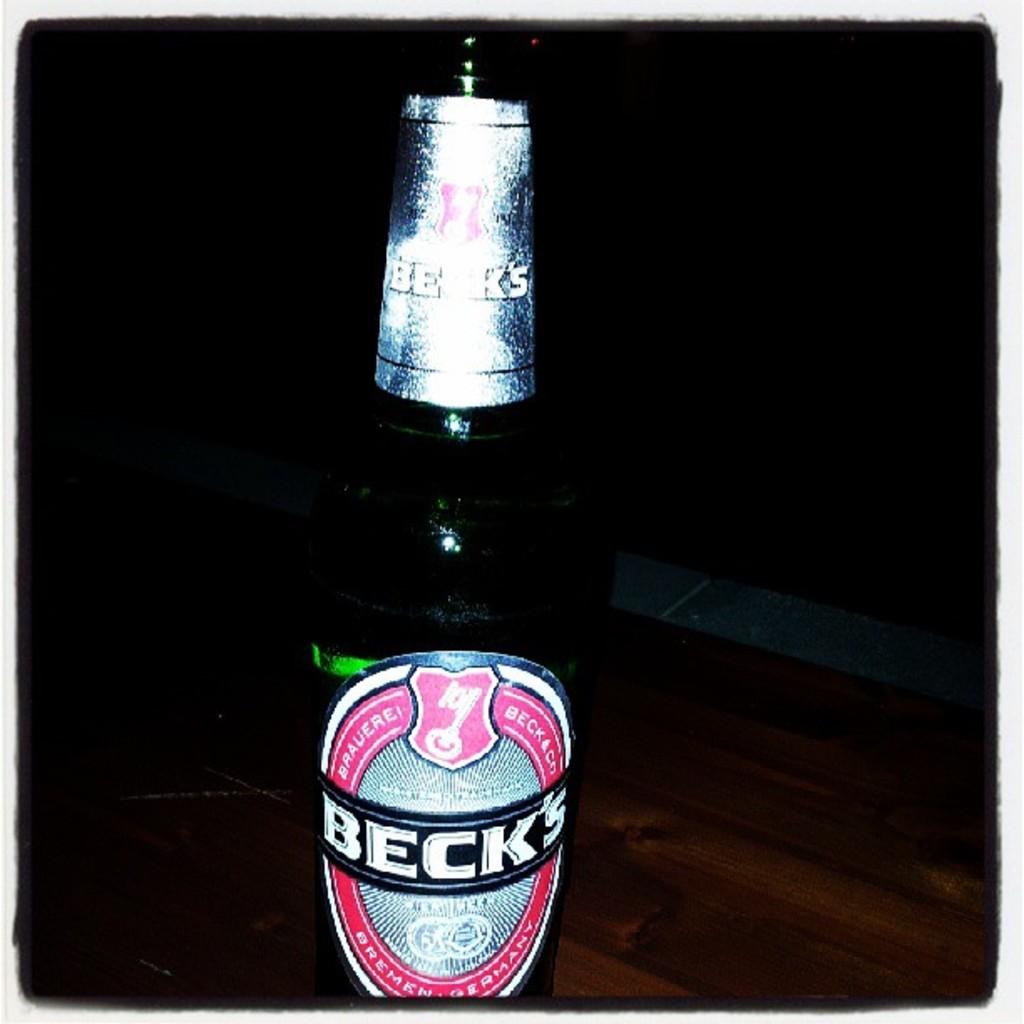What brand of beer is this?
Make the answer very short. Beck's. 